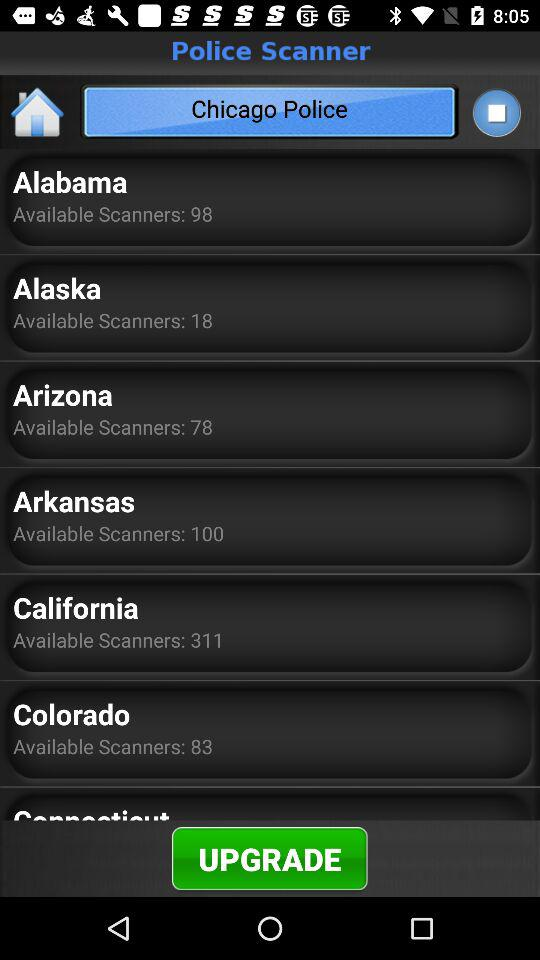How many scanners are available in California? There are 311 scanners available in California. 